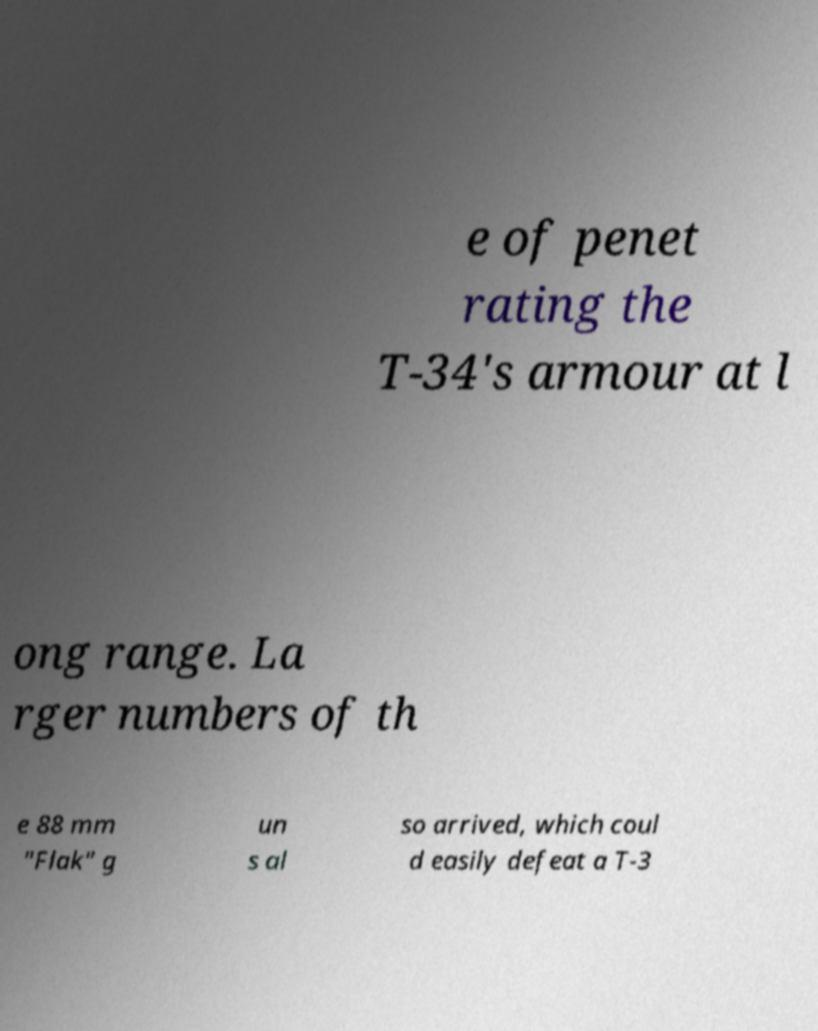What messages or text are displayed in this image? I need them in a readable, typed format. e of penet rating the T-34's armour at l ong range. La rger numbers of th e 88 mm "Flak" g un s al so arrived, which coul d easily defeat a T-3 